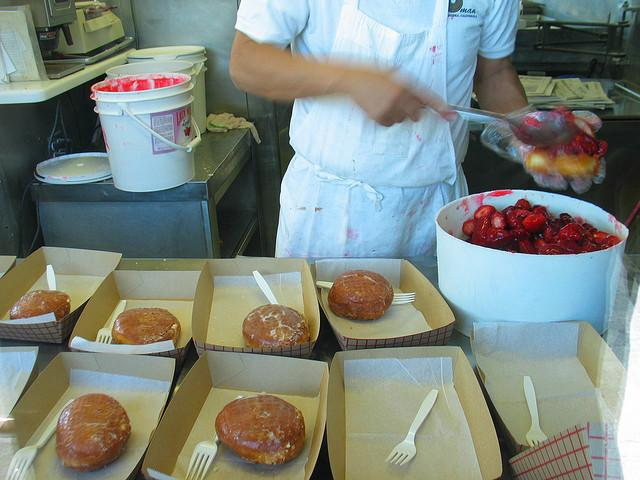What type of filling is in the donuts? Please explain your reasoning. fruit. The donuts have strawberries in them. 